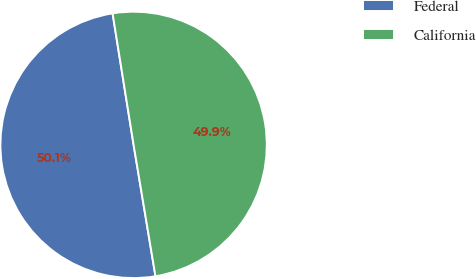Convert chart to OTSL. <chart><loc_0><loc_0><loc_500><loc_500><pie_chart><fcel>Federal<fcel>California<nl><fcel>50.1%<fcel>49.9%<nl></chart> 